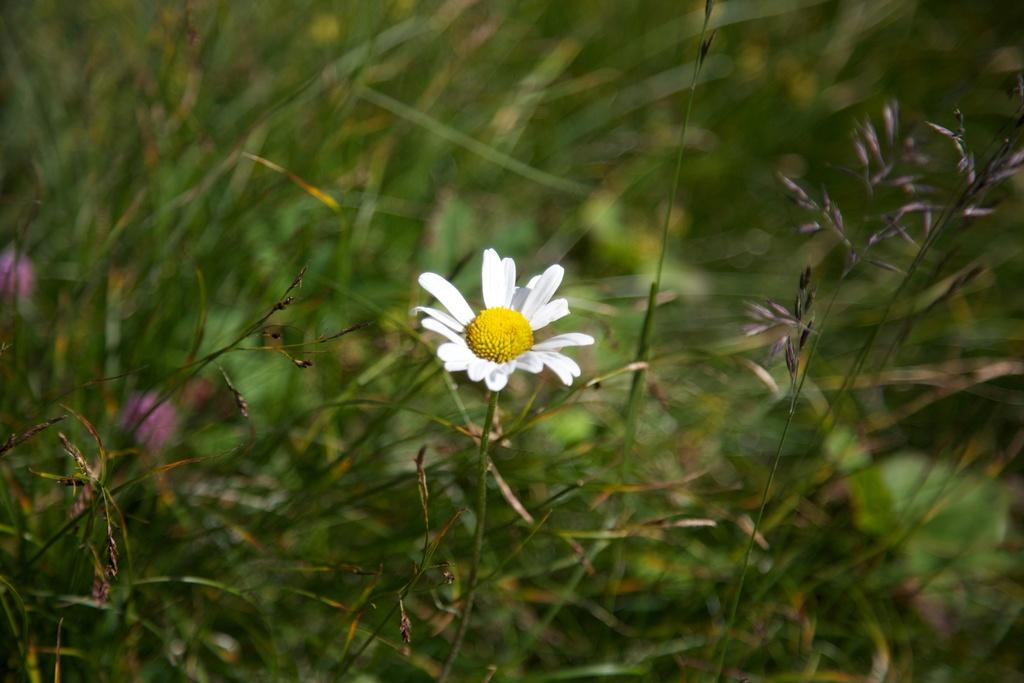What is the main subject of the image? There is a stem with a flower in the image. What else can be seen in the image besides the flower? There are plants in the background of the image. How would you describe the background of the image? The background is blurry. Can you see a pig wearing a hat with wings in the image? No, there is no pig wearing a hat with wings in the image. 